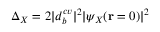Convert formula to latex. <formula><loc_0><loc_0><loc_500><loc_500>\Delta _ { X } = 2 | d _ { b } ^ { c v } | ^ { 2 } | \psi _ { X } ( \mathbf r = 0 ) | ^ { 2 }</formula> 